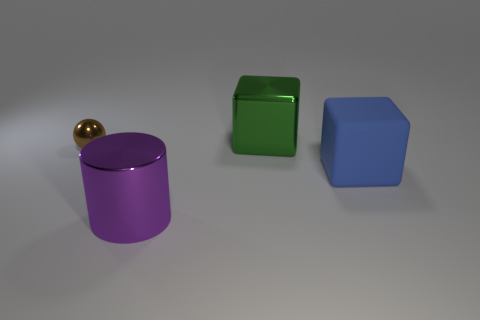Considering these objects, what concepts might they be used to illustrate? These objects could be used to illustrate various educational concepts such as geometry, discussing the properties of shapes like cylinders and cubes. They could also serve as a visual aid for explaining principles of light and shadow, color theory with the different colored objects, or even materials science by examining the metallic surfaces and their qualities. 